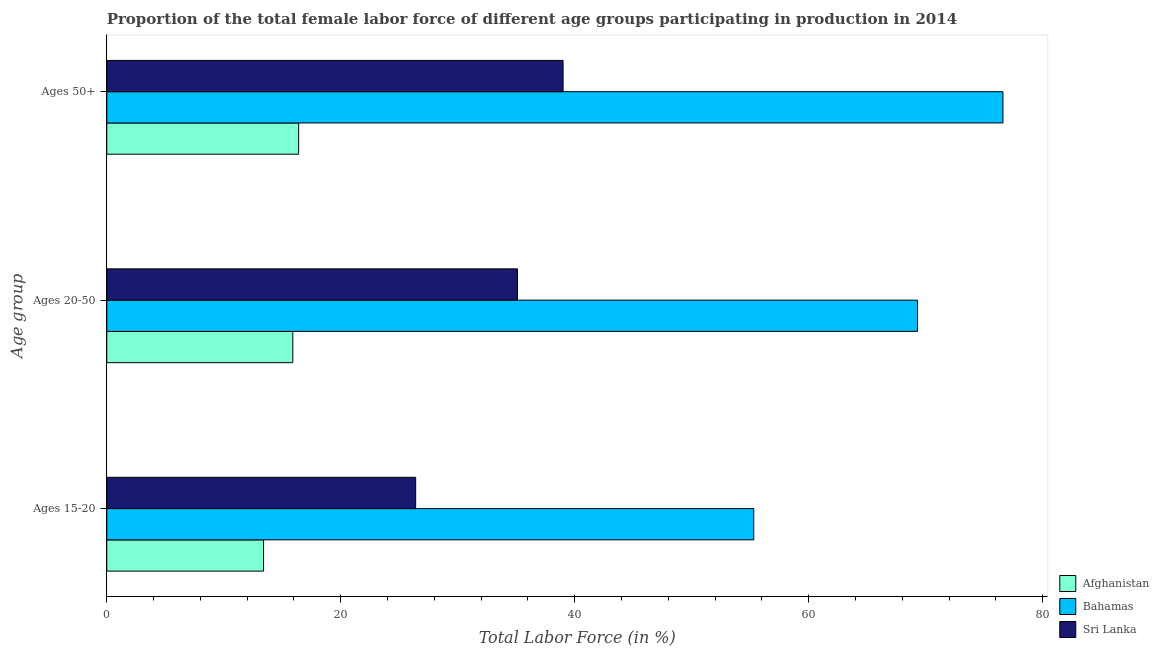How many different coloured bars are there?
Offer a very short reply. 3. Are the number of bars per tick equal to the number of legend labels?
Ensure brevity in your answer.  Yes. Are the number of bars on each tick of the Y-axis equal?
Ensure brevity in your answer.  Yes. What is the label of the 3rd group of bars from the top?
Ensure brevity in your answer.  Ages 15-20. What is the percentage of female labor force above age 50 in Sri Lanka?
Your answer should be compact. 39. Across all countries, what is the maximum percentage of female labor force within the age group 20-50?
Offer a very short reply. 69.3. Across all countries, what is the minimum percentage of female labor force within the age group 15-20?
Your answer should be very brief. 13.4. In which country was the percentage of female labor force within the age group 20-50 maximum?
Make the answer very short. Bahamas. In which country was the percentage of female labor force within the age group 20-50 minimum?
Offer a very short reply. Afghanistan. What is the total percentage of female labor force within the age group 20-50 in the graph?
Your answer should be very brief. 120.3. What is the difference between the percentage of female labor force within the age group 15-20 in Bahamas and that in Afghanistan?
Ensure brevity in your answer.  41.9. What is the difference between the percentage of female labor force within the age group 20-50 in Afghanistan and the percentage of female labor force above age 50 in Bahamas?
Your answer should be very brief. -60.7. What is the average percentage of female labor force within the age group 15-20 per country?
Ensure brevity in your answer.  31.7. What is the difference between the percentage of female labor force within the age group 20-50 and percentage of female labor force within the age group 15-20 in Bahamas?
Provide a succinct answer. 14. In how many countries, is the percentage of female labor force within the age group 20-50 greater than 48 %?
Offer a very short reply. 1. What is the ratio of the percentage of female labor force above age 50 in Afghanistan to that in Bahamas?
Provide a succinct answer. 0.21. Is the percentage of female labor force above age 50 in Sri Lanka less than that in Afghanistan?
Your response must be concise. No. What is the difference between the highest and the second highest percentage of female labor force within the age group 15-20?
Offer a very short reply. 28.9. What is the difference between the highest and the lowest percentage of female labor force within the age group 15-20?
Give a very brief answer. 41.9. In how many countries, is the percentage of female labor force above age 50 greater than the average percentage of female labor force above age 50 taken over all countries?
Keep it short and to the point. 1. Is the sum of the percentage of female labor force above age 50 in Bahamas and Sri Lanka greater than the maximum percentage of female labor force within the age group 20-50 across all countries?
Give a very brief answer. Yes. What does the 2nd bar from the top in Ages 20-50 represents?
Your answer should be compact. Bahamas. What does the 2nd bar from the bottom in Ages 20-50 represents?
Offer a terse response. Bahamas. Is it the case that in every country, the sum of the percentage of female labor force within the age group 15-20 and percentage of female labor force within the age group 20-50 is greater than the percentage of female labor force above age 50?
Offer a terse response. Yes. How many bars are there?
Offer a very short reply. 9. Are all the bars in the graph horizontal?
Make the answer very short. Yes. What is the difference between two consecutive major ticks on the X-axis?
Give a very brief answer. 20. Does the graph contain any zero values?
Ensure brevity in your answer.  No. Where does the legend appear in the graph?
Give a very brief answer. Bottom right. How many legend labels are there?
Give a very brief answer. 3. What is the title of the graph?
Make the answer very short. Proportion of the total female labor force of different age groups participating in production in 2014. What is the label or title of the Y-axis?
Give a very brief answer. Age group. What is the Total Labor Force (in %) in Afghanistan in Ages 15-20?
Give a very brief answer. 13.4. What is the Total Labor Force (in %) in Bahamas in Ages 15-20?
Make the answer very short. 55.3. What is the Total Labor Force (in %) in Sri Lanka in Ages 15-20?
Make the answer very short. 26.4. What is the Total Labor Force (in %) of Afghanistan in Ages 20-50?
Your answer should be compact. 15.9. What is the Total Labor Force (in %) in Bahamas in Ages 20-50?
Make the answer very short. 69.3. What is the Total Labor Force (in %) in Sri Lanka in Ages 20-50?
Offer a very short reply. 35.1. What is the Total Labor Force (in %) in Afghanistan in Ages 50+?
Make the answer very short. 16.4. What is the Total Labor Force (in %) in Bahamas in Ages 50+?
Your response must be concise. 76.6. What is the Total Labor Force (in %) in Sri Lanka in Ages 50+?
Make the answer very short. 39. Across all Age group, what is the maximum Total Labor Force (in %) of Afghanistan?
Ensure brevity in your answer.  16.4. Across all Age group, what is the maximum Total Labor Force (in %) in Bahamas?
Your answer should be very brief. 76.6. Across all Age group, what is the maximum Total Labor Force (in %) in Sri Lanka?
Provide a succinct answer. 39. Across all Age group, what is the minimum Total Labor Force (in %) in Afghanistan?
Make the answer very short. 13.4. Across all Age group, what is the minimum Total Labor Force (in %) in Bahamas?
Your answer should be compact. 55.3. Across all Age group, what is the minimum Total Labor Force (in %) in Sri Lanka?
Keep it short and to the point. 26.4. What is the total Total Labor Force (in %) of Afghanistan in the graph?
Your answer should be compact. 45.7. What is the total Total Labor Force (in %) of Bahamas in the graph?
Keep it short and to the point. 201.2. What is the total Total Labor Force (in %) of Sri Lanka in the graph?
Your answer should be compact. 100.5. What is the difference between the Total Labor Force (in %) of Sri Lanka in Ages 15-20 and that in Ages 20-50?
Ensure brevity in your answer.  -8.7. What is the difference between the Total Labor Force (in %) of Afghanistan in Ages 15-20 and that in Ages 50+?
Make the answer very short. -3. What is the difference between the Total Labor Force (in %) in Bahamas in Ages 15-20 and that in Ages 50+?
Your answer should be very brief. -21.3. What is the difference between the Total Labor Force (in %) of Sri Lanka in Ages 15-20 and that in Ages 50+?
Your answer should be compact. -12.6. What is the difference between the Total Labor Force (in %) in Afghanistan in Ages 20-50 and that in Ages 50+?
Make the answer very short. -0.5. What is the difference between the Total Labor Force (in %) in Afghanistan in Ages 15-20 and the Total Labor Force (in %) in Bahamas in Ages 20-50?
Keep it short and to the point. -55.9. What is the difference between the Total Labor Force (in %) in Afghanistan in Ages 15-20 and the Total Labor Force (in %) in Sri Lanka in Ages 20-50?
Make the answer very short. -21.7. What is the difference between the Total Labor Force (in %) in Bahamas in Ages 15-20 and the Total Labor Force (in %) in Sri Lanka in Ages 20-50?
Your answer should be very brief. 20.2. What is the difference between the Total Labor Force (in %) of Afghanistan in Ages 15-20 and the Total Labor Force (in %) of Bahamas in Ages 50+?
Offer a terse response. -63.2. What is the difference between the Total Labor Force (in %) in Afghanistan in Ages 15-20 and the Total Labor Force (in %) in Sri Lanka in Ages 50+?
Your answer should be very brief. -25.6. What is the difference between the Total Labor Force (in %) of Bahamas in Ages 15-20 and the Total Labor Force (in %) of Sri Lanka in Ages 50+?
Offer a very short reply. 16.3. What is the difference between the Total Labor Force (in %) in Afghanistan in Ages 20-50 and the Total Labor Force (in %) in Bahamas in Ages 50+?
Your answer should be compact. -60.7. What is the difference between the Total Labor Force (in %) in Afghanistan in Ages 20-50 and the Total Labor Force (in %) in Sri Lanka in Ages 50+?
Offer a very short reply. -23.1. What is the difference between the Total Labor Force (in %) of Bahamas in Ages 20-50 and the Total Labor Force (in %) of Sri Lanka in Ages 50+?
Offer a very short reply. 30.3. What is the average Total Labor Force (in %) of Afghanistan per Age group?
Offer a very short reply. 15.23. What is the average Total Labor Force (in %) in Bahamas per Age group?
Offer a terse response. 67.07. What is the average Total Labor Force (in %) of Sri Lanka per Age group?
Make the answer very short. 33.5. What is the difference between the Total Labor Force (in %) in Afghanistan and Total Labor Force (in %) in Bahamas in Ages 15-20?
Your answer should be very brief. -41.9. What is the difference between the Total Labor Force (in %) of Afghanistan and Total Labor Force (in %) of Sri Lanka in Ages 15-20?
Keep it short and to the point. -13. What is the difference between the Total Labor Force (in %) in Bahamas and Total Labor Force (in %) in Sri Lanka in Ages 15-20?
Keep it short and to the point. 28.9. What is the difference between the Total Labor Force (in %) in Afghanistan and Total Labor Force (in %) in Bahamas in Ages 20-50?
Your answer should be compact. -53.4. What is the difference between the Total Labor Force (in %) in Afghanistan and Total Labor Force (in %) in Sri Lanka in Ages 20-50?
Make the answer very short. -19.2. What is the difference between the Total Labor Force (in %) in Bahamas and Total Labor Force (in %) in Sri Lanka in Ages 20-50?
Your answer should be very brief. 34.2. What is the difference between the Total Labor Force (in %) in Afghanistan and Total Labor Force (in %) in Bahamas in Ages 50+?
Ensure brevity in your answer.  -60.2. What is the difference between the Total Labor Force (in %) in Afghanistan and Total Labor Force (in %) in Sri Lanka in Ages 50+?
Your answer should be compact. -22.6. What is the difference between the Total Labor Force (in %) of Bahamas and Total Labor Force (in %) of Sri Lanka in Ages 50+?
Your response must be concise. 37.6. What is the ratio of the Total Labor Force (in %) in Afghanistan in Ages 15-20 to that in Ages 20-50?
Your answer should be compact. 0.84. What is the ratio of the Total Labor Force (in %) of Bahamas in Ages 15-20 to that in Ages 20-50?
Offer a terse response. 0.8. What is the ratio of the Total Labor Force (in %) in Sri Lanka in Ages 15-20 to that in Ages 20-50?
Your answer should be very brief. 0.75. What is the ratio of the Total Labor Force (in %) in Afghanistan in Ages 15-20 to that in Ages 50+?
Give a very brief answer. 0.82. What is the ratio of the Total Labor Force (in %) of Bahamas in Ages 15-20 to that in Ages 50+?
Offer a terse response. 0.72. What is the ratio of the Total Labor Force (in %) of Sri Lanka in Ages 15-20 to that in Ages 50+?
Your response must be concise. 0.68. What is the ratio of the Total Labor Force (in %) in Afghanistan in Ages 20-50 to that in Ages 50+?
Give a very brief answer. 0.97. What is the ratio of the Total Labor Force (in %) of Bahamas in Ages 20-50 to that in Ages 50+?
Your response must be concise. 0.9. What is the difference between the highest and the second highest Total Labor Force (in %) in Afghanistan?
Your answer should be compact. 0.5. What is the difference between the highest and the lowest Total Labor Force (in %) of Bahamas?
Keep it short and to the point. 21.3. What is the difference between the highest and the lowest Total Labor Force (in %) of Sri Lanka?
Keep it short and to the point. 12.6. 